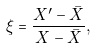Convert formula to latex. <formula><loc_0><loc_0><loc_500><loc_500>\xi = \frac { X ^ { \prime } - { \bar { X } } } { X - { \bar { X } } } ,</formula> 